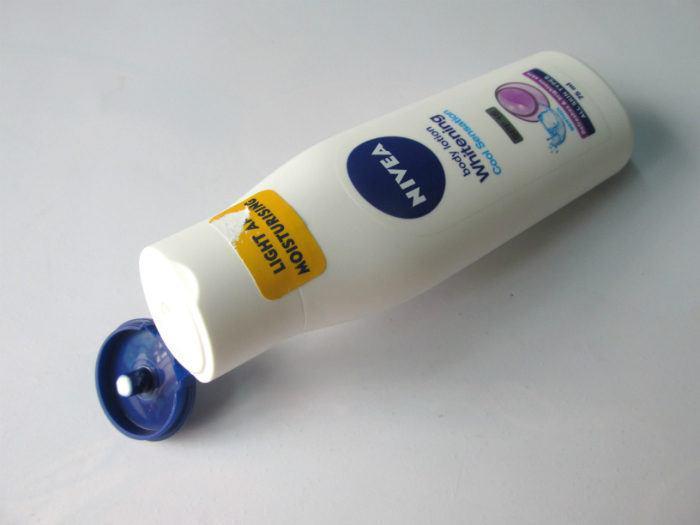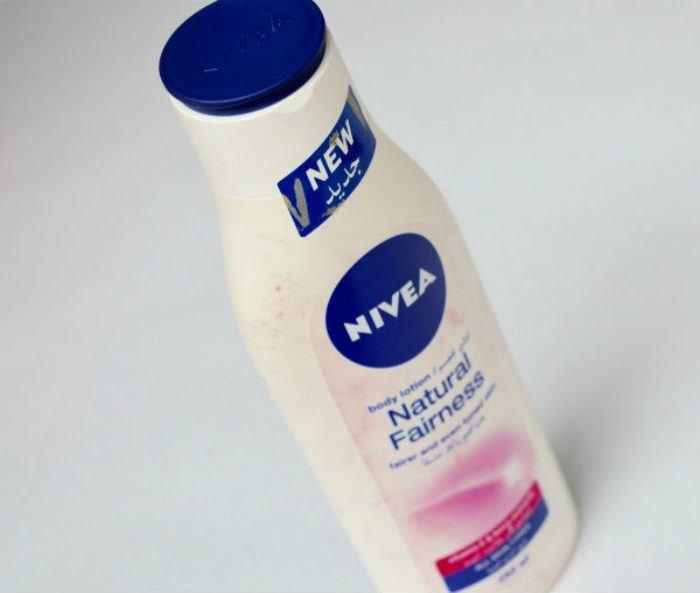The first image is the image on the left, the second image is the image on the right. Given the left and right images, does the statement "There is a torn sticker on the bottle in the image on the left." hold true? Answer yes or no. Yes. The first image is the image on the left, the second image is the image on the right. Examine the images to the left and right. Is the description "All lotion bottles have dark blue caps." accurate? Answer yes or no. Yes. 